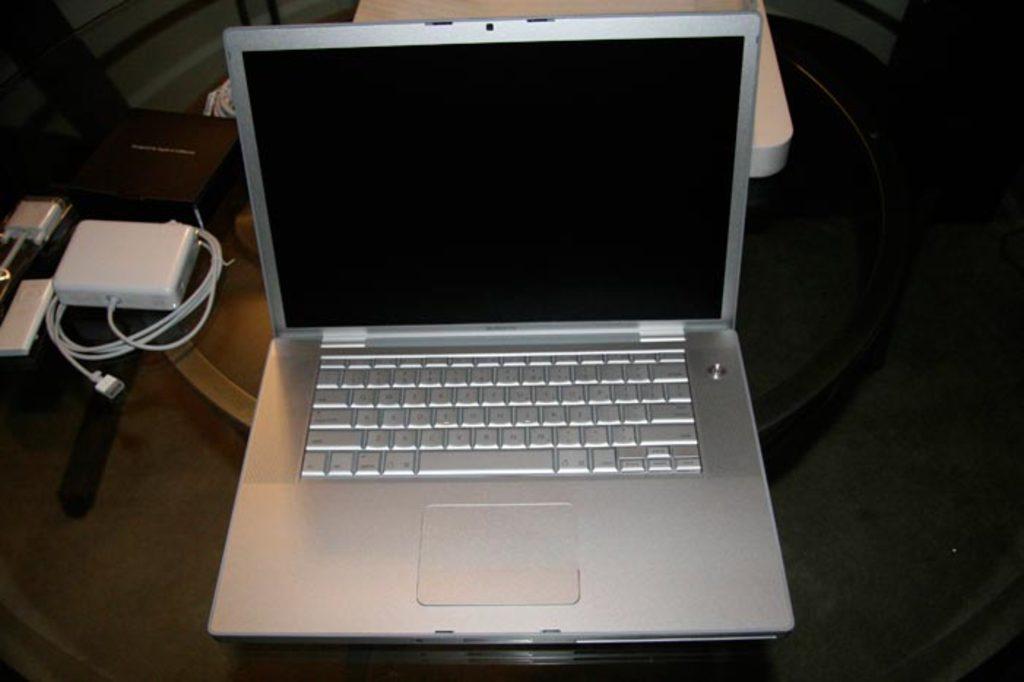How would you summarize this image in a sentence or two? In the image we can see there is a laptop kept on the table and there is a charger box kept on the glass table. 